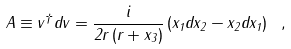<formula> <loc_0><loc_0><loc_500><loc_500>A \equiv v ^ { \dag } d v = \frac { i } { 2 r \left ( r + x _ { 3 } \right ) } \left ( x _ { 1 } d x _ { 2 } - x _ { 2 } d x _ { 1 } \right ) \ ,</formula> 